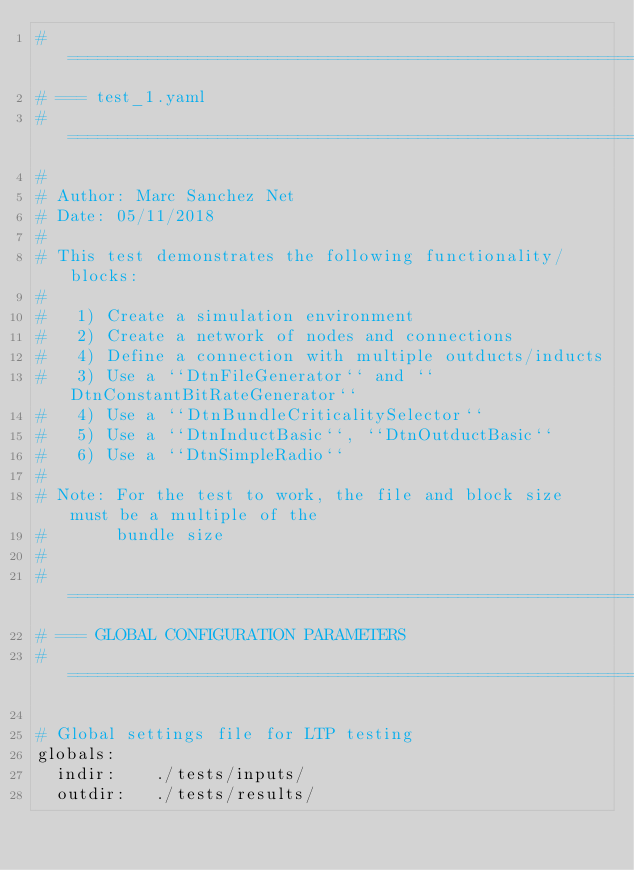<code> <loc_0><loc_0><loc_500><loc_500><_YAML_># =============================================================================
# === test_1.yaml
# =============================================================================
# 
# Author: Marc Sanchez Net
# Date: 05/11/2018
# 
# This test demonstrates the following functionality/blocks:
#
#   1) Create a simulation environment
#   2) Create a network of nodes and connections
#   4) Define a connection with multiple outducts/inducts
#   3) Use a ``DtnFileGenerator`` and ``DtnConstantBitRateGenerator``
#   4) Use a ``DtnBundleCriticalitySelector``
#   5) Use a ``DtnInductBasic``, ``DtnOutductBasic``
#   6) Use a ``DtnSimpleRadio``
#
# Note: For the test to work, the file and block size must be a multiple of the
#       bundle size
#
# =============================================================================
# === GLOBAL CONFIGURATION PARAMETERS
# =============================================================================

# Global settings file for LTP testing
globals:
  indir:    ./tests/inputs/
  outdir:   ./tests/results/</code> 